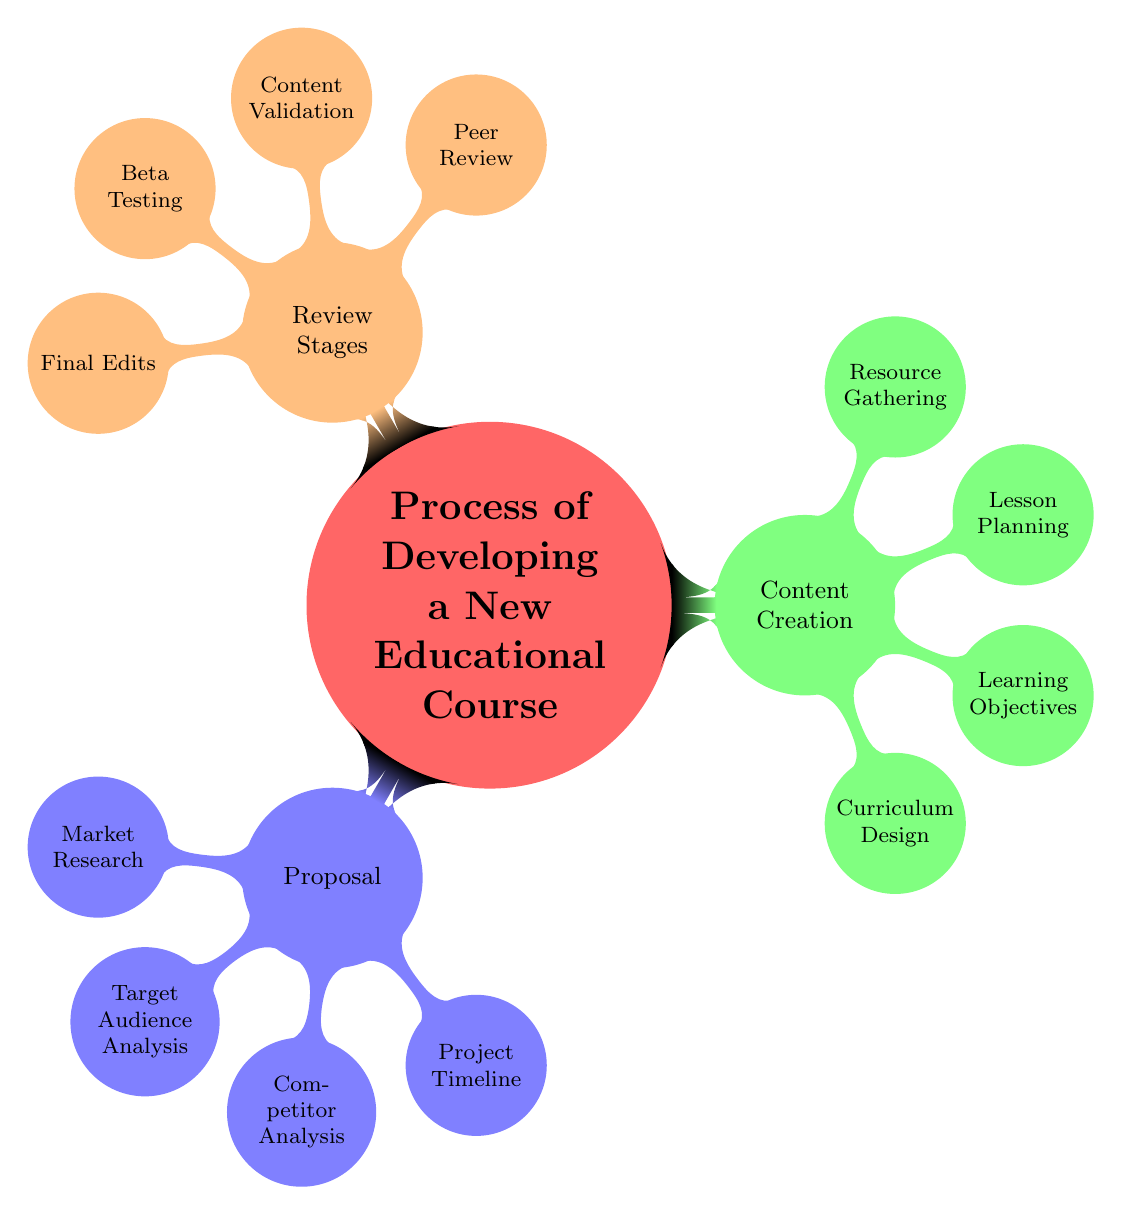What is the main topic of the diagram? The main topic is clearly labeled at the center of the mind map and reads "Process of Developing a New Educational Course."
Answer: Process of Developing a New Educational Course How many subtopics are there? The diagram shows three primary branches arising from the main topic: Proposal, Content Creation, and Review Stages. Therefore, there are three subtopics.
Answer: 3 What are the elements listed under the "Content Creation" subtopic? The subtopic "Content Creation" consists of four elements: Curriculum Design, Learning Objectives, Lesson Planning, and Resource Gathering, as seen in the corresponding branch.
Answer: Curriculum Design, Learning Objectives, Lesson Planning, Resource Gathering Which subtopic has the most elements? By examining the number of elements under each subtopic, Proposal has 4 elements, Content Creation has 4 elements, and Review Stages has 4 elements, meaning all subtopics have an equal number of elements.
Answer: Equal (4 elements each) What is the relationship between "Market Research" and "Beta Testing"? The two terms belong to different subtopics with no direct relationship since "Market Research" is under Proposal and "Beta Testing" is under Review Stages; they are independent stages within the course development process.
Answer: Independent List one element under the "Review Stages" subtopic. The "Review Stages" subtopic includes elements such as Peer Review, Content Validation, Beta Testing, and Final Edits; any of these can be listed as an example.
Answer: Peer Review How many elements are there in total in the diagram? To find the total number of elements, we count 4 from Proposal, 4 from Content Creation, and 4 from Review Stages, which adds up to 12 elements in total.
Answer: 12 What stage comes before "Final Edits"? Within the Review Stages, "Beta Testing" is the stage that comes immediately before "Final Edits," as per the order displayed in the mind map.
Answer: Beta Testing Identify one element that is part of the "Proposal" subtopic. Among the elements under the "Proposal" subtopic, options include Market Research, Target Audience Analysis, Competitor Analysis, and Project Timeline; any of these could be the answer.
Answer: Market Research 